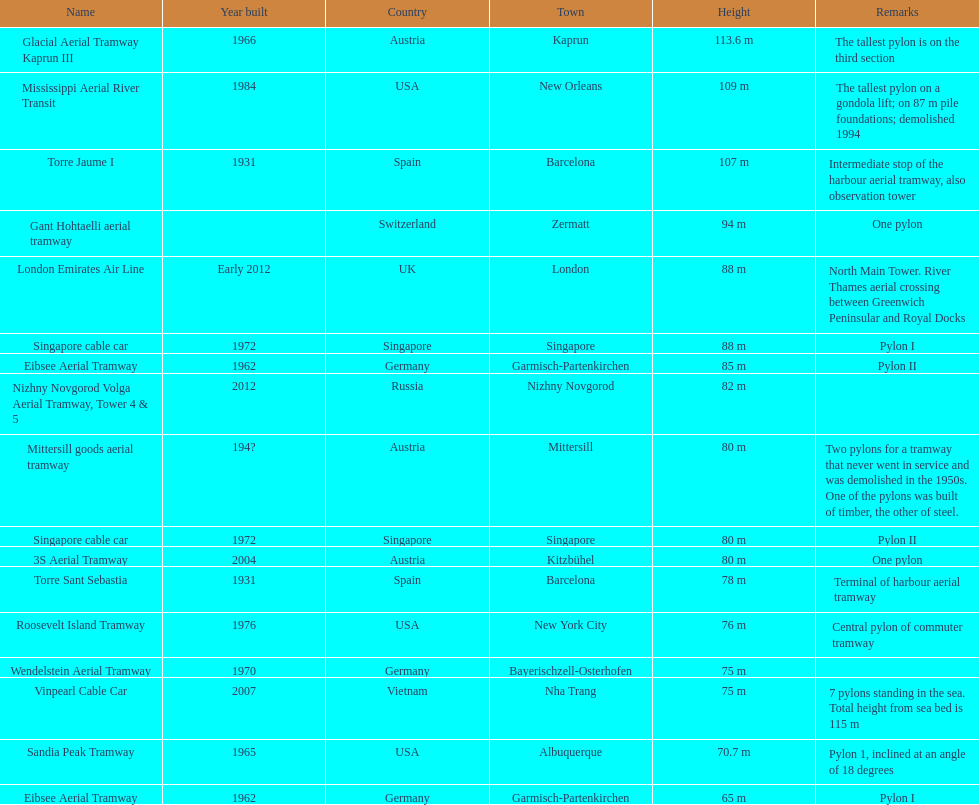On which pylon are the most observations made? Mittersill goods aerial tramway. 